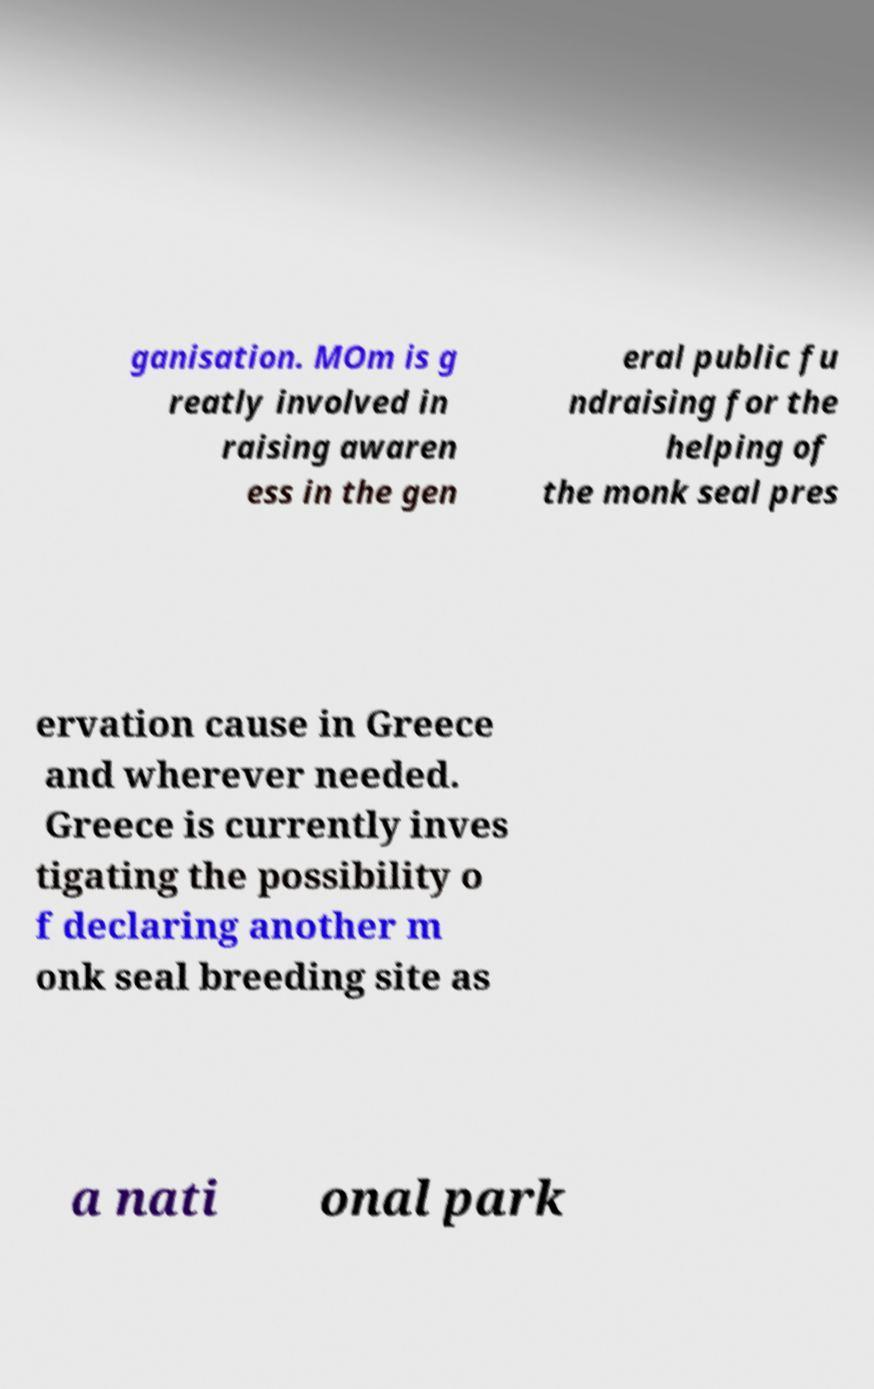There's text embedded in this image that I need extracted. Can you transcribe it verbatim? ganisation. MOm is g reatly involved in raising awaren ess in the gen eral public fu ndraising for the helping of the monk seal pres ervation cause in Greece and wherever needed. Greece is currently inves tigating the possibility o f declaring another m onk seal breeding site as a nati onal park 